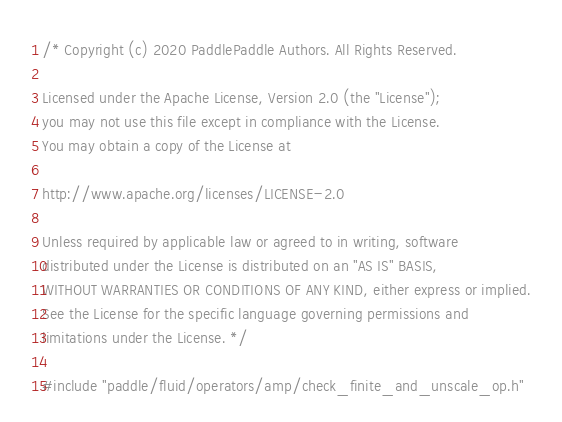Convert code to text. <code><loc_0><loc_0><loc_500><loc_500><_Cuda_>/* Copyright (c) 2020 PaddlePaddle Authors. All Rights Reserved.

Licensed under the Apache License, Version 2.0 (the "License");
you may not use this file except in compliance with the License.
You may obtain a copy of the License at

http://www.apache.org/licenses/LICENSE-2.0

Unless required by applicable law or agreed to in writing, software
distributed under the License is distributed on an "AS IS" BASIS,
WITHOUT WARRANTIES OR CONDITIONS OF ANY KIND, either express or implied.
See the License for the specific language governing permissions and
limitations under the License. */

#include "paddle/fluid/operators/amp/check_finite_and_unscale_op.h"</code> 